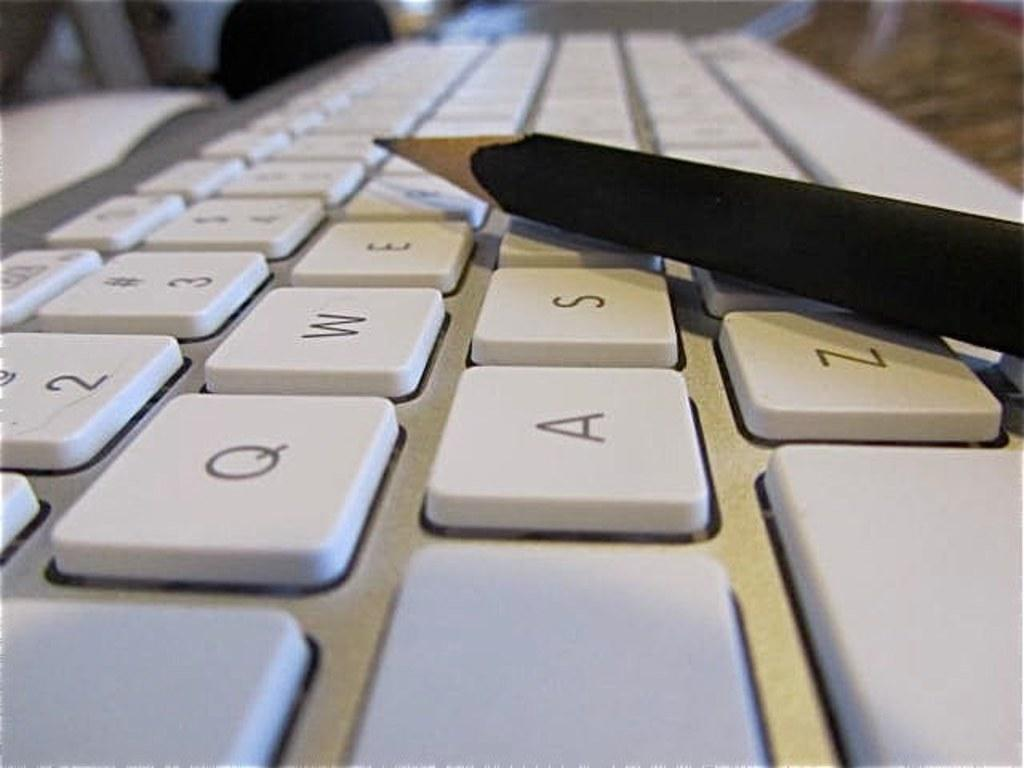Provide a one-sentence caption for the provided image. A keyboard has a pencil on top of it, which is next to the letters E, S, and Z. 